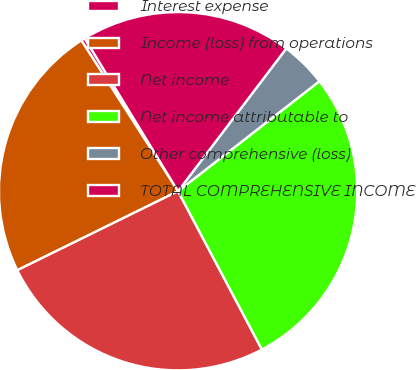<chart> <loc_0><loc_0><loc_500><loc_500><pie_chart><fcel>Interest expense<fcel>Income (loss) from operations<fcel>Net income<fcel>Net income attributable to<fcel>Other comprehensive (loss)<fcel>TOTAL COMPREHENSIVE INCOME<nl><fcel>0.35%<fcel>23.2%<fcel>25.48%<fcel>27.77%<fcel>4.15%<fcel>19.05%<nl></chart> 